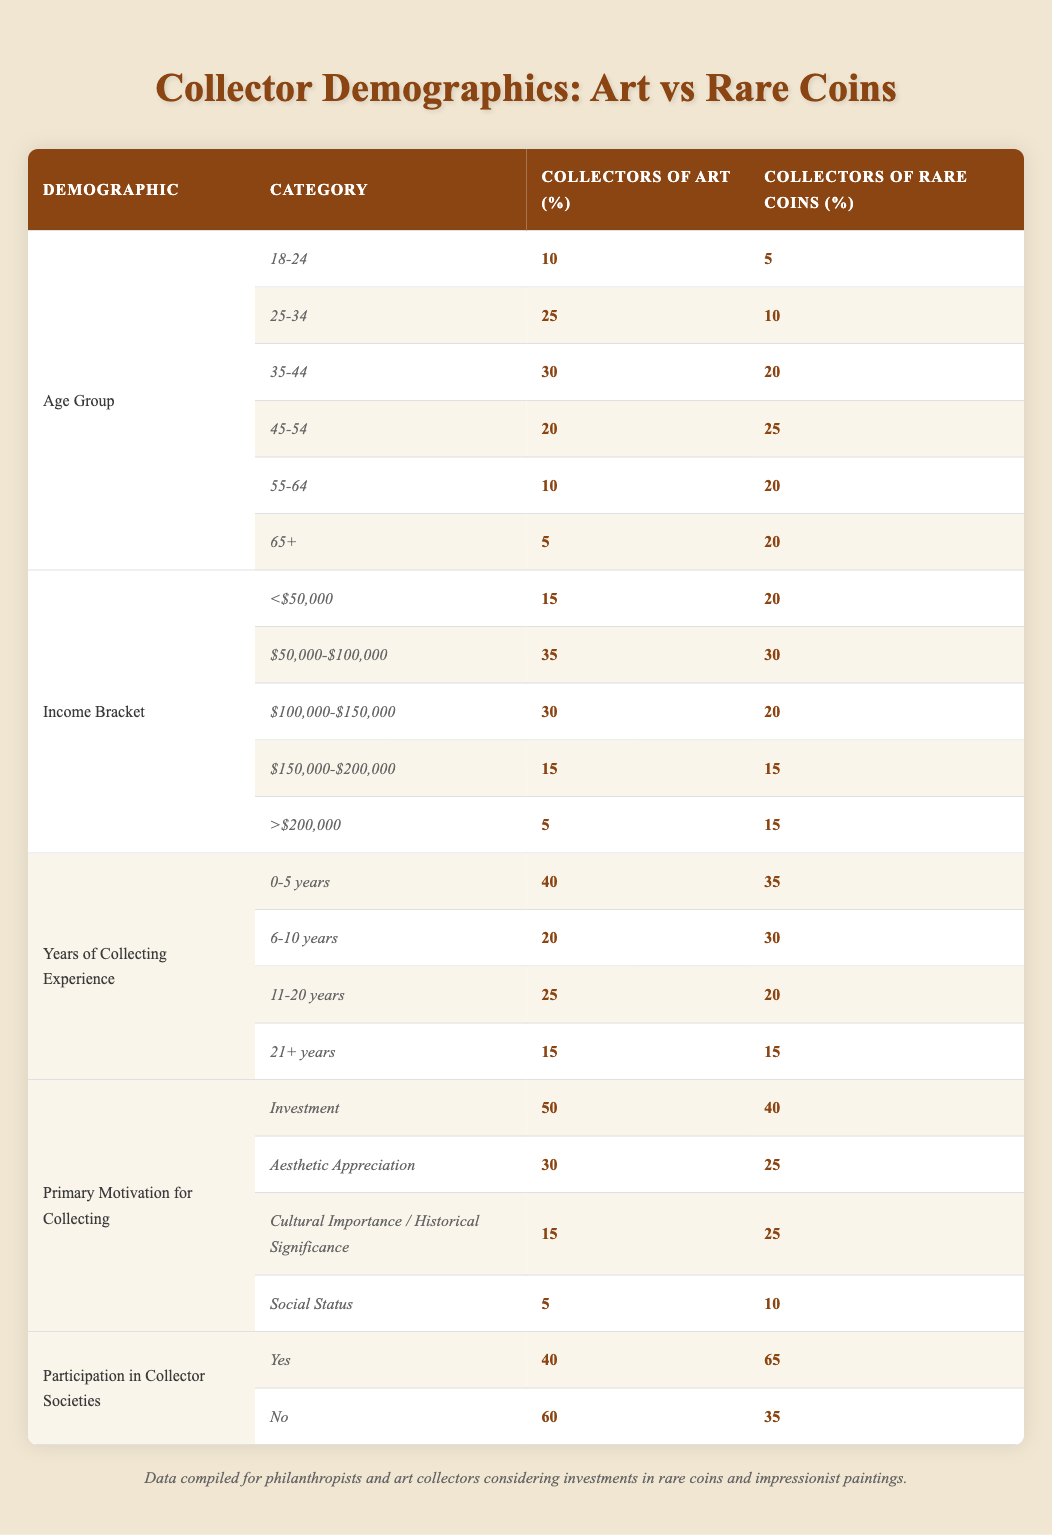What percentage of art collectors are in the age group 35-44? Referring to the age group data for art collectors, under the age group 35-44, the table indicates 30%.
Answer: 30% How many more collectors of rare coins are aged 65+ compared to collectors of art in the same age group? The table shows that there are 20% of rare coin collectors aged 65+ and 5% of art collectors aged 65+. The difference is 20 - 5 = 15%.
Answer: 15% Is there a larger percentage of rare coin collectors in the income bracket of $50,000-$100,000 compared to art collectors? Yes, the table shows that 30% of rare coin collectors fall in the income bracket of $50,000-$100,000, while 35% of art collectors do.
Answer: No What is the total percentage of collectors who have 0-5 years of collecting experience for both categories combined? For art collectors, the percentage is 40%, and for rare coin collectors, it's 35%. Combined, this adds up to 40 + 35 = 75%.
Answer: 75% How does the percentage of collectors motivated by social status differ between art and rare coins? According to the data, 5% of art collectors are motivated by social status, while 10% of rare coin collectors are motivated by the same aspect. The difference is 10 - 5 = 5%.
Answer: 5% What is the average percentage of collectors who participate in collector societies for both groups? The table shows 40% of art collectors and 65% of rare coin collectors participate in societies. The average can be calculated as (40 + 65) / 2 = 52.5%.
Answer: 52.5% Are most collectors of art driven by investment motives rather than aesthetic appreciation? Yes, 50% of art collectors are motivated by investment, compared to 30% who are motivated by aesthetic appreciation.
Answer: Yes Which demographic has the highest percentage of collectors for art and rare coins together when considering years of collecting experience? For art collectors, the highest percentage is 40% in the 0-5 years category and for rare coins, it is 35% in the same category. Therefore, the highest combined percentage is 40% from art collectors.
Answer: 40% 